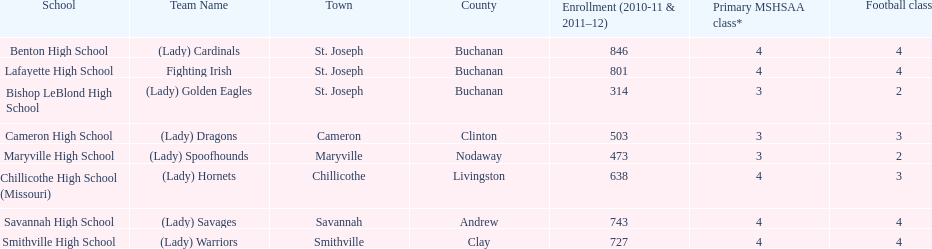How many groups are named after birds? 2. 